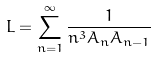<formula> <loc_0><loc_0><loc_500><loc_500>L = \sum _ { n = 1 } ^ { \infty } \frac { 1 } { n ^ { 3 } A _ { n } A _ { n - 1 } }</formula> 